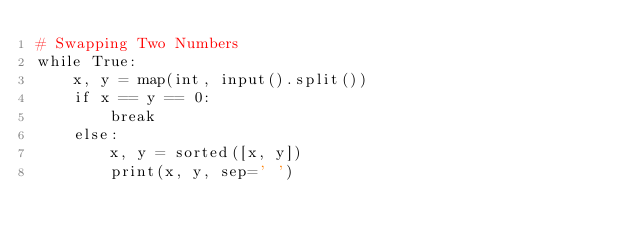<code> <loc_0><loc_0><loc_500><loc_500><_Python_># Swapping Two Numbers
while True:
    x, y = map(int, input().split())
    if x == y == 0:
        break
    else:
        x, y = sorted([x, y])
        print(x, y, sep=' ')
</code> 